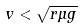<formula> <loc_0><loc_0><loc_500><loc_500>v < \sqrt { r \mu g }</formula> 